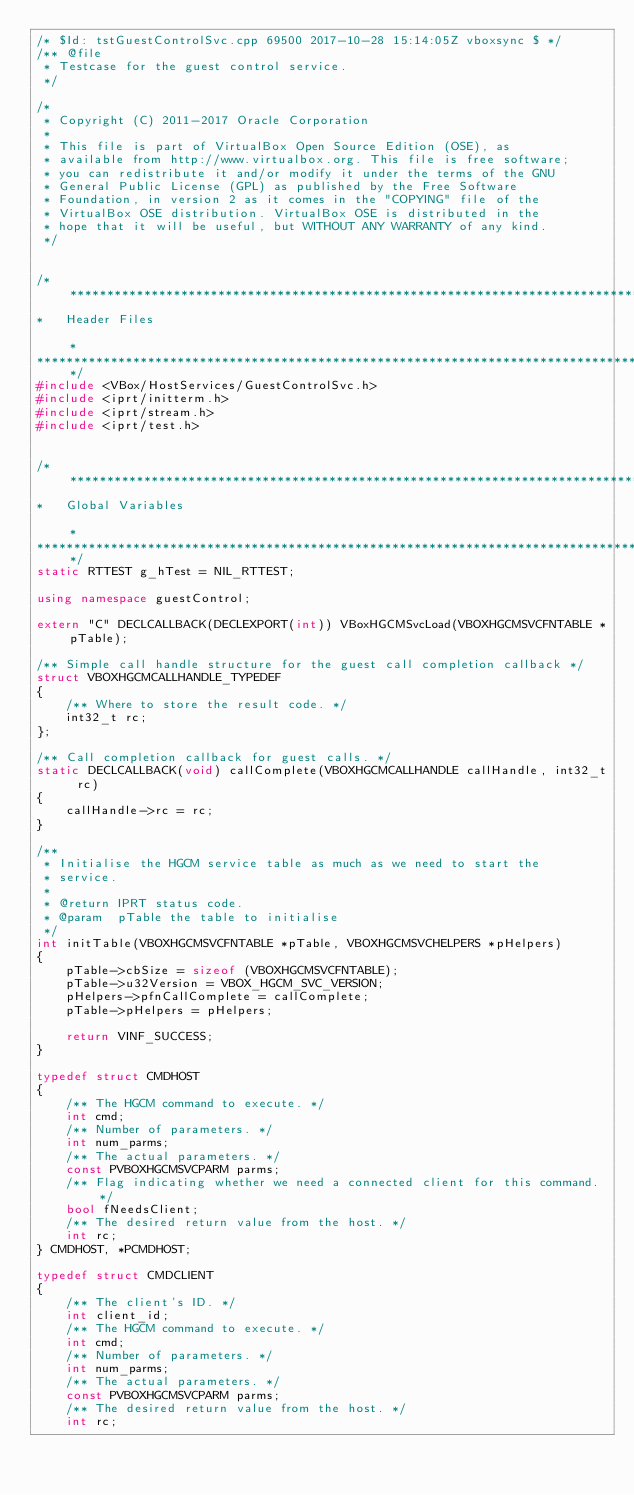<code> <loc_0><loc_0><loc_500><loc_500><_C++_>/* $Id: tstGuestControlSvc.cpp 69500 2017-10-28 15:14:05Z vboxsync $ */
/** @file
 * Testcase for the guest control service.
 */

/*
 * Copyright (C) 2011-2017 Oracle Corporation
 *
 * This file is part of VirtualBox Open Source Edition (OSE), as
 * available from http://www.virtualbox.org. This file is free software;
 * you can redistribute it and/or modify it under the terms of the GNU
 * General Public License (GPL) as published by the Free Software
 * Foundation, in version 2 as it comes in the "COPYING" file of the
 * VirtualBox OSE distribution. VirtualBox OSE is distributed in the
 * hope that it will be useful, but WITHOUT ANY WARRANTY of any kind.
 */


/*********************************************************************************************************************************
*   Header Files                                                                                                                 *
*********************************************************************************************************************************/
#include <VBox/HostServices/GuestControlSvc.h>
#include <iprt/initterm.h>
#include <iprt/stream.h>
#include <iprt/test.h>


/*********************************************************************************************************************************
*   Global Variables                                                                                                             *
*********************************************************************************************************************************/
static RTTEST g_hTest = NIL_RTTEST;

using namespace guestControl;

extern "C" DECLCALLBACK(DECLEXPORT(int)) VBoxHGCMSvcLoad(VBOXHGCMSVCFNTABLE *pTable);

/** Simple call handle structure for the guest call completion callback */
struct VBOXHGCMCALLHANDLE_TYPEDEF
{
    /** Where to store the result code. */
    int32_t rc;
};

/** Call completion callback for guest calls. */
static DECLCALLBACK(void) callComplete(VBOXHGCMCALLHANDLE callHandle, int32_t rc)
{
    callHandle->rc = rc;
}

/**
 * Initialise the HGCM service table as much as we need to start the
 * service.
 *
 * @return IPRT status code.
 * @param  pTable the table to initialise
 */
int initTable(VBOXHGCMSVCFNTABLE *pTable, VBOXHGCMSVCHELPERS *pHelpers)
{
    pTable->cbSize = sizeof (VBOXHGCMSVCFNTABLE);
    pTable->u32Version = VBOX_HGCM_SVC_VERSION;
    pHelpers->pfnCallComplete = callComplete;
    pTable->pHelpers = pHelpers;

    return VINF_SUCCESS;
}

typedef struct CMDHOST
{
    /** The HGCM command to execute. */
    int cmd;
    /** Number of parameters. */
    int num_parms;
    /** The actual parameters. */
    const PVBOXHGCMSVCPARM parms;
    /** Flag indicating whether we need a connected client for this command. */
    bool fNeedsClient;
    /** The desired return value from the host. */
    int rc;
} CMDHOST, *PCMDHOST;

typedef struct CMDCLIENT
{
    /** The client's ID. */
    int client_id;
    /** The HGCM command to execute. */
    int cmd;
    /** Number of parameters. */
    int num_parms;
    /** The actual parameters. */
    const PVBOXHGCMSVCPARM parms;
    /** The desired return value from the host. */
    int rc;</code> 